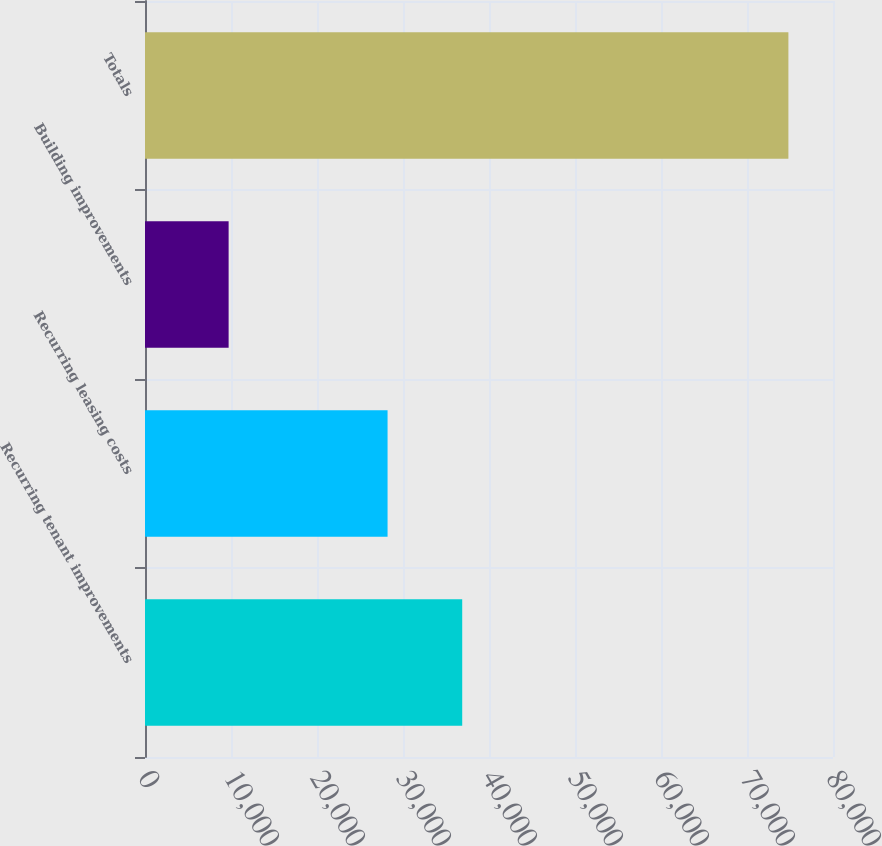<chart> <loc_0><loc_0><loc_500><loc_500><bar_chart><fcel>Recurring tenant improvements<fcel>Recurring leasing costs<fcel>Building improvements<fcel>Totals<nl><fcel>36885<fcel>28205<fcel>9724<fcel>74814<nl></chart> 